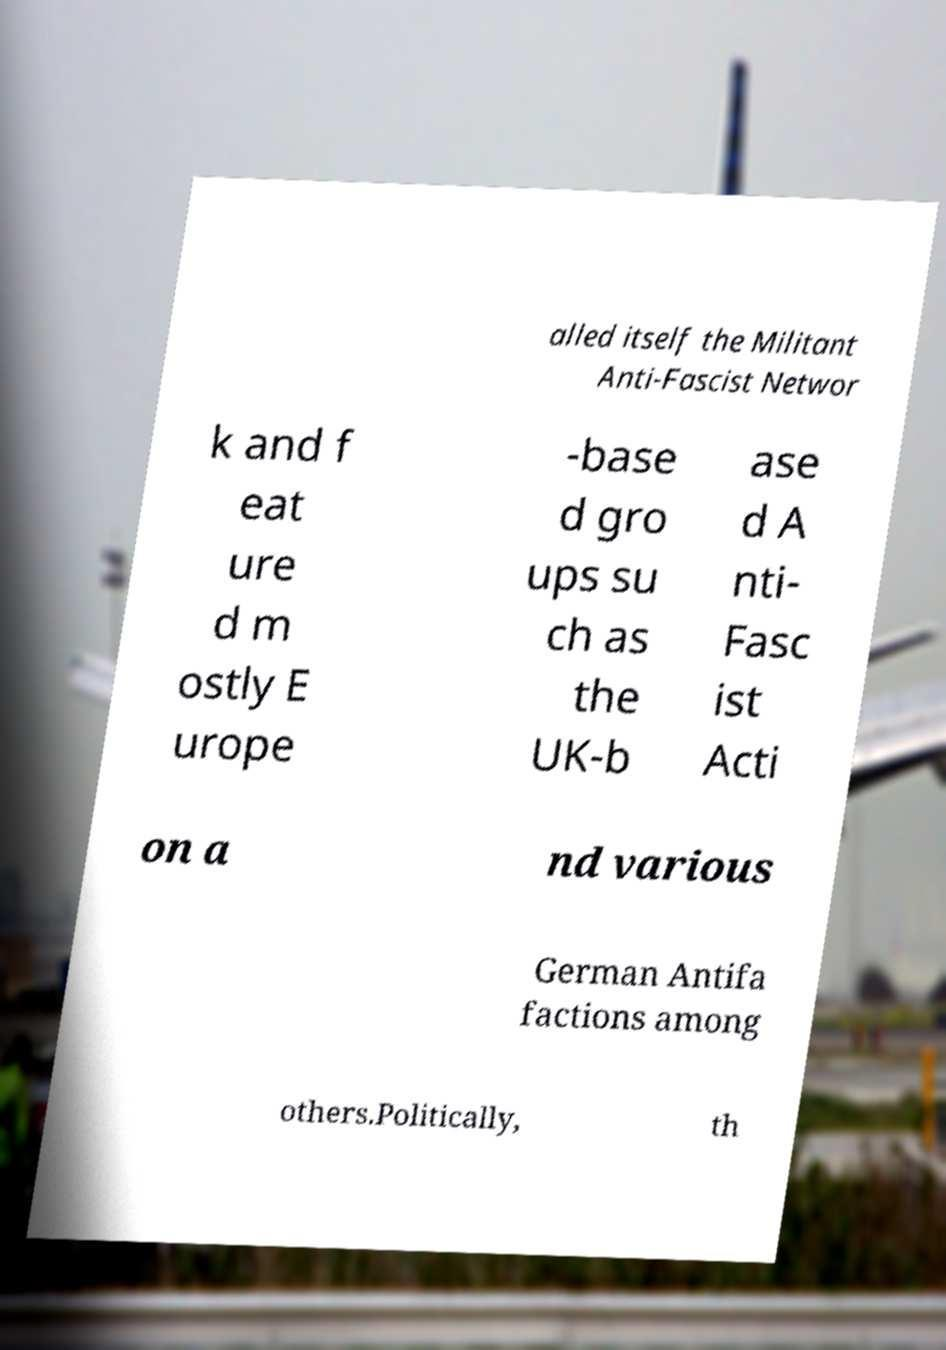There's text embedded in this image that I need extracted. Can you transcribe it verbatim? alled itself the Militant Anti-Fascist Networ k and f eat ure d m ostly E urope -base d gro ups su ch as the UK-b ase d A nti- Fasc ist Acti on a nd various German Antifa factions among others.Politically, th 